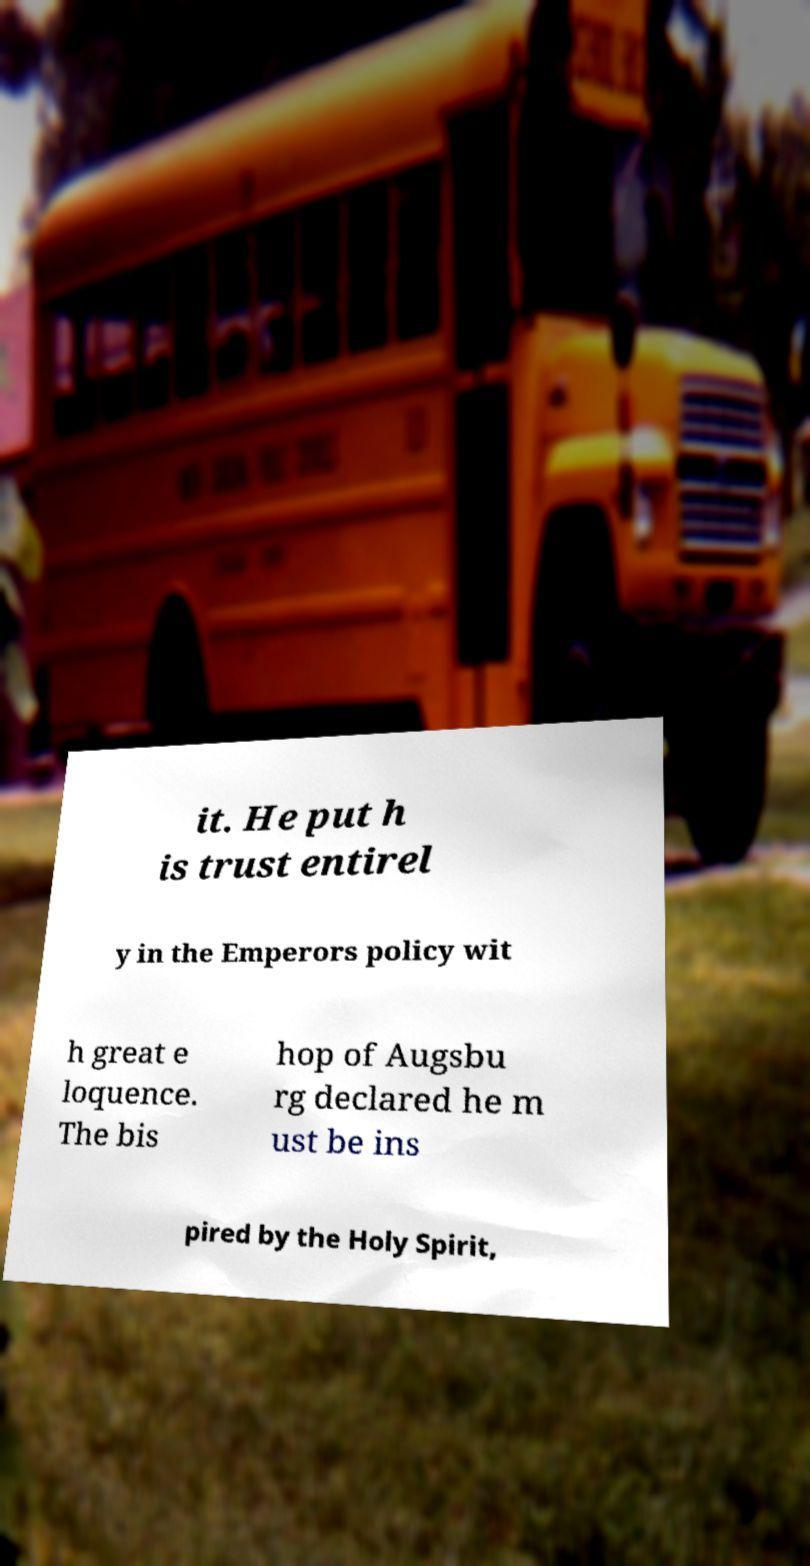Please identify and transcribe the text found in this image. it. He put h is trust entirel y in the Emperors policy wit h great e loquence. The bis hop of Augsbu rg declared he m ust be ins pired by the Holy Spirit, 